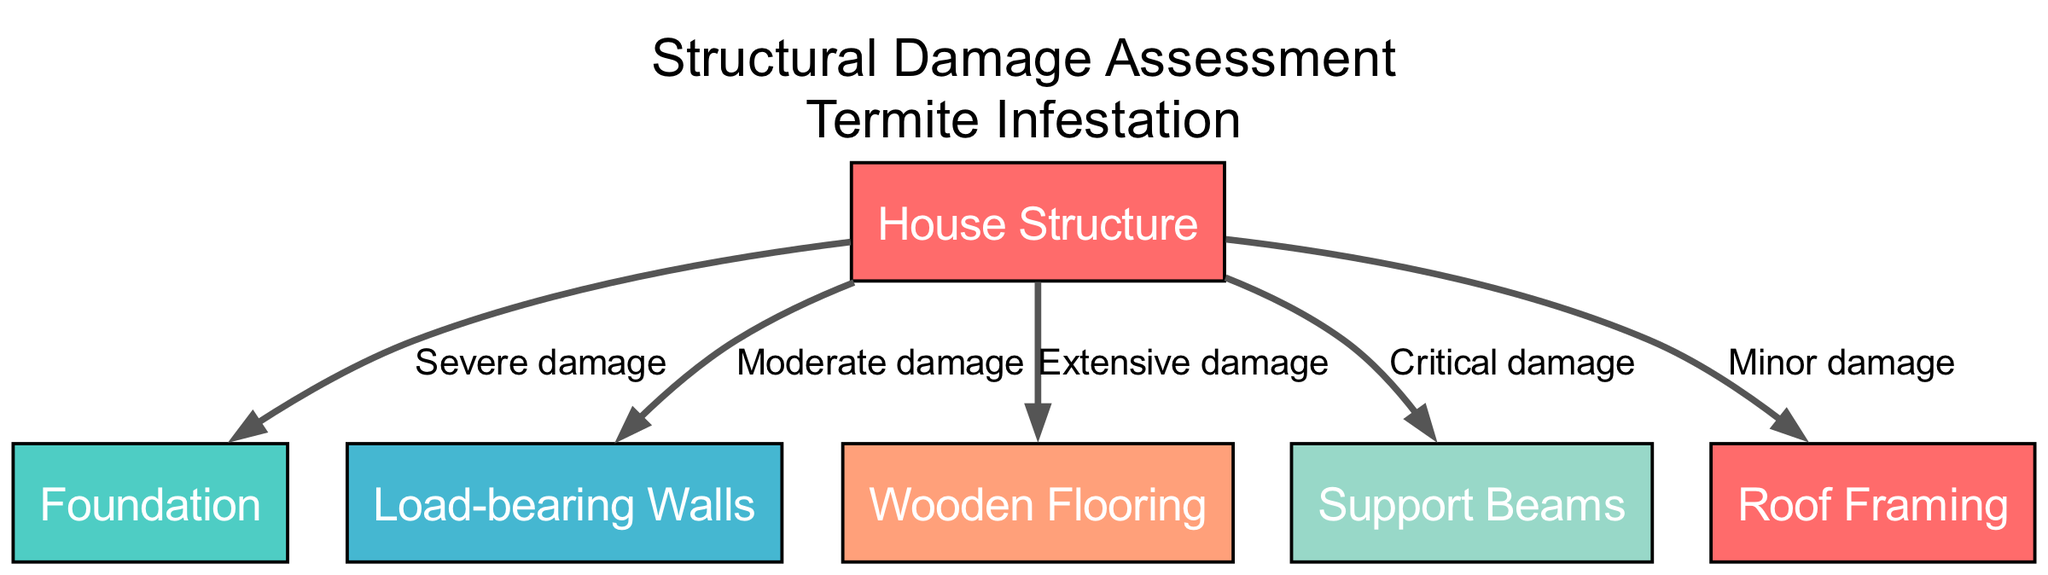What is the condition of the support beams? The diagram indicates that the condition of the support beams is labeled as "Critical damage." This is explicitly stated as an edge label connecting the house structure to the support beams.
Answer: Critical damage How many nodes are present in the diagram? The nodes represent different structural elements of the house. Counting them, there are six nodes in total: house structure, foundation, load-bearing walls, wooden flooring, support beams, and roof framing.
Answer: Six What type of damage is indicated on the roof? The damage to the roof is labeled as "Minor damage" according to the edge label connecting the house structure to the roof framing.
Answer: Minor damage Which structural component has the highest level of damage? The diagram shows that the wooden flooring has the designation "Extensive damage," which is considered the highest level of damage among the options being discussed.
Answer: Extensive damage Compare the damage levels between the load-bearing walls and the foundation. The load-bearing walls are indicated as having "Moderate damage," while the foundation has "Severe damage." Thus, the foundation has a higher level of damage compared to the load-bearing walls.
Answer: Foundation: Severe damage; Load-bearing walls: Moderate damage What is the relationship label connecting the house structure to the walls? The connection between the house structure and the walls is labeled as "Moderate damage," which is detailed on the edge linking these two nodes.
Answer: Moderate damage How many edges are included in the diagram? Each edge connects a structural component to the house structure, indicating a specific type of damage. There are five edges in total, each representing a different damage level to the house components.
Answer: Five Which component has a "Severe damage" label? The diagram specifies that the foundation is the component with a "Severe damage" label, which is clear from the edge that connects it to the house structure.
Answer: Foundation Which structural element is experiencing "Extensive damage"? The edge connecting the house structure to the wooden flooring indicates that the wooden flooring is experiencing "Extensive damage" as per the label on that edge.
Answer: Wooden Flooring 